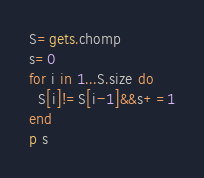Convert code to text. <code><loc_0><loc_0><loc_500><loc_500><_Ruby_>S=gets.chomp
s=0
for i in 1...S.size do
  S[i]!=S[i-1]&&s+=1
end
p s</code> 